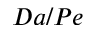<formula> <loc_0><loc_0><loc_500><loc_500>D a / P e</formula> 